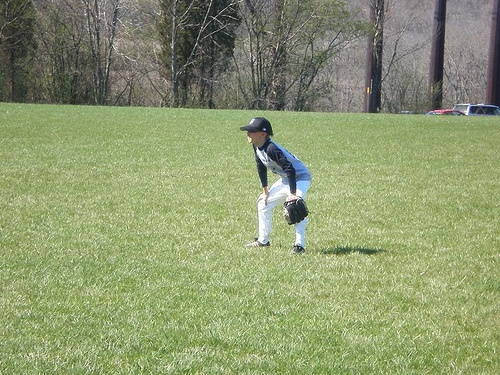Describe the objects in this image and their specific colors. I can see people in black, white, gray, and darkgray tones, baseball glove in black, gray, white, and darkgray tones, truck in black, gray, darkgray, and navy tones, and car in black, gray, lightpink, and purple tones in this image. 